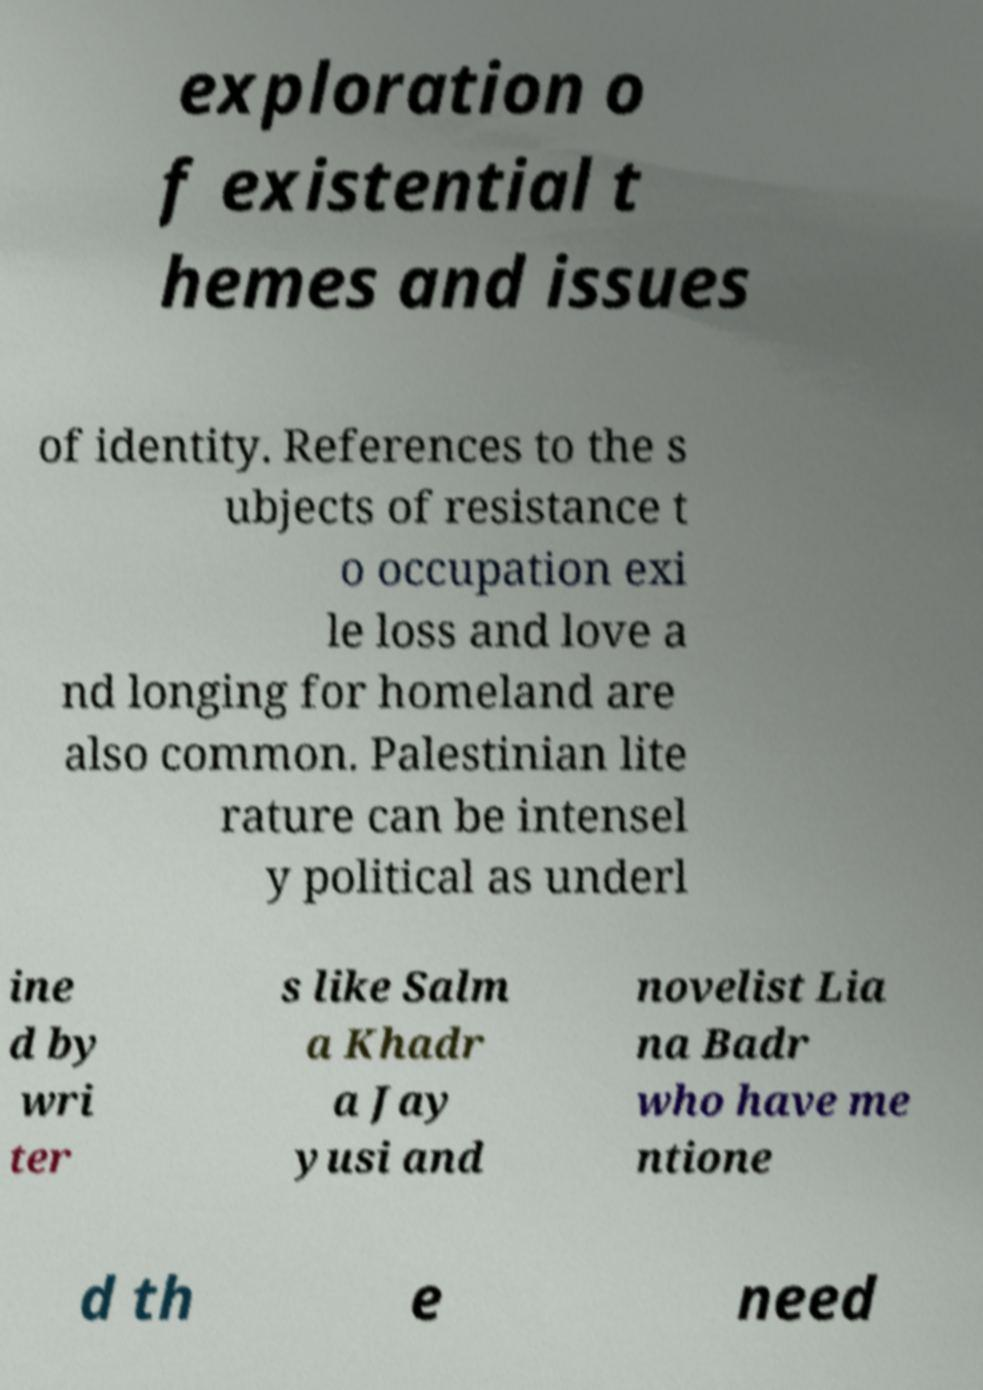There's text embedded in this image that I need extracted. Can you transcribe it verbatim? exploration o f existential t hemes and issues of identity. References to the s ubjects of resistance t o occupation exi le loss and love a nd longing for homeland are also common. Palestinian lite rature can be intensel y political as underl ine d by wri ter s like Salm a Khadr a Jay yusi and novelist Lia na Badr who have me ntione d th e need 